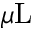<formula> <loc_0><loc_0><loc_500><loc_500>\mu L</formula> 